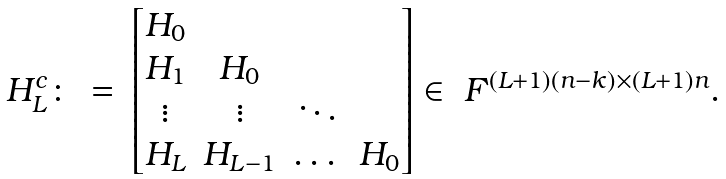<formula> <loc_0><loc_0><loc_500><loc_500>\begin{array} { r c l } H ^ { c } _ { L } \colon & = & \begin{bmatrix} H _ { 0 } & & & \\ H _ { 1 } & H _ { 0 } & & \\ \vdots & \vdots & \ddots & \\ H _ { L } & H _ { L - 1 } & \dots & H _ { 0 } \end{bmatrix} \in \ F ^ { ( L + 1 ) ( n - k ) \times ( L + 1 ) n } . \end{array}</formula> 